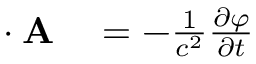<formula> <loc_0><loc_0><loc_500><loc_500>\begin{array} { r l } { \nabla \cdot A } & = - { \frac { 1 } { c ^ { 2 } } } { \frac { \partial \varphi } { \partial t } } } \end{array}</formula> 